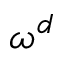<formula> <loc_0><loc_0><loc_500><loc_500>\omega ^ { d }</formula> 